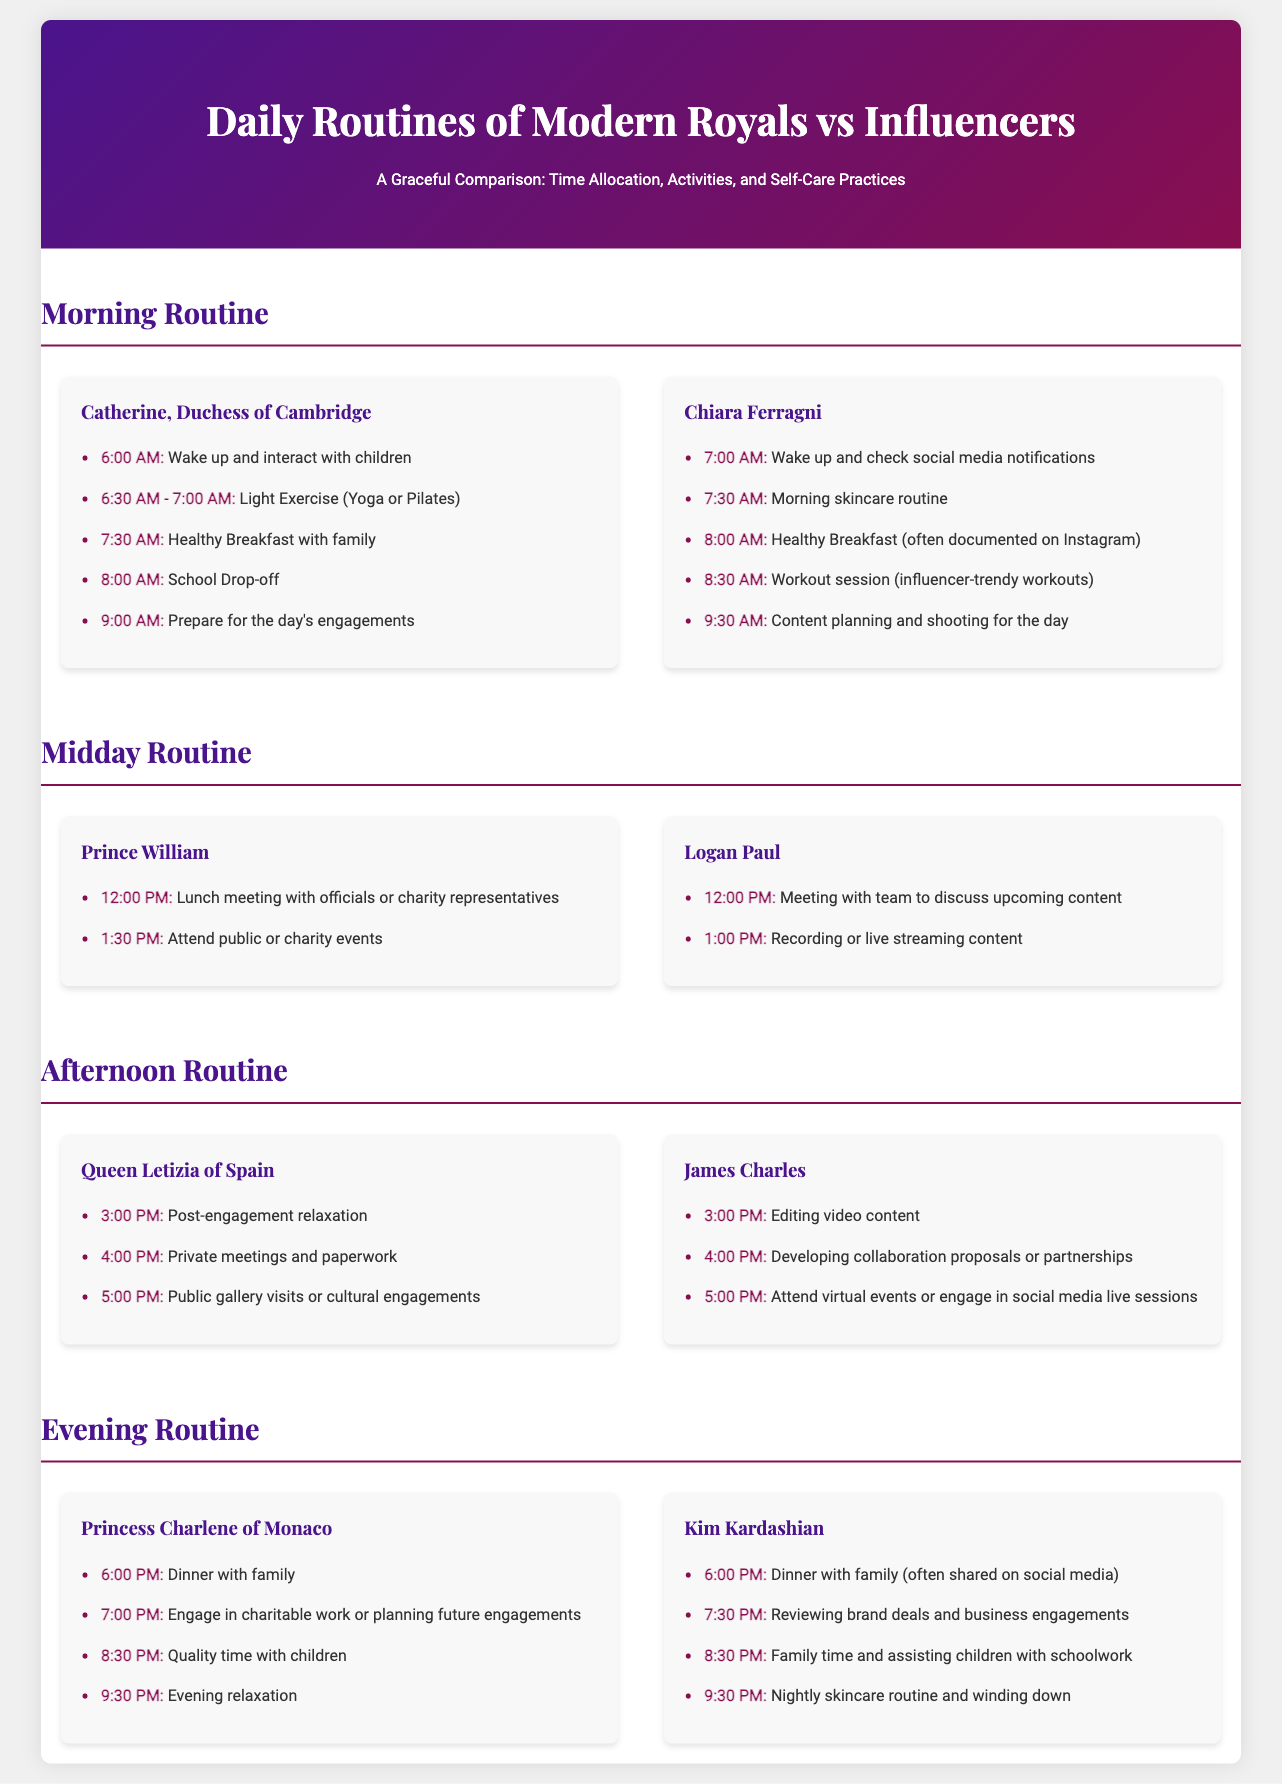What time does Catherine, Duchess of Cambridge, wake up? The document states that she wakes up at 6:00 AM.
Answer: 6:00 AM What activity does Chiara Ferragni do at 7:30 AM? The document mentions that she has her morning skincare routine at this time.
Answer: Morning skincare routine How long does Prince William allocate for lunch meetings? The document indicates that he has lunch meetings starting at 12:00 PM.
Answer: 12:00 PM Who engages in video editing at 3:00 PM? James Charles is noted for editing video content at this time.
Answer: James Charles What is Princess Charlene's first evening activity? The document specifies that she has dinner with family at 6:00 PM.
Answer: Dinner with family How does Kim Kardashian's evening routine start? The document states that her evening begins with dinner at 6:00 PM.
Answer: Dinner with family Which royal participates in public events at 1:30 PM? Prince William is associated with attending public or charity events at this time.
Answer: Prince William What common activity can both royals and influencers be seen doing with their children in the evening? The document highlights quality time or engagement with their children.
Answer: Quality time with children What is the last activity noted for both Chiara Ferragni and James Charles in the midday routine? Both influencers focus on content planning; Chiara on planning and James on partnerships.
Answer: Content planning 